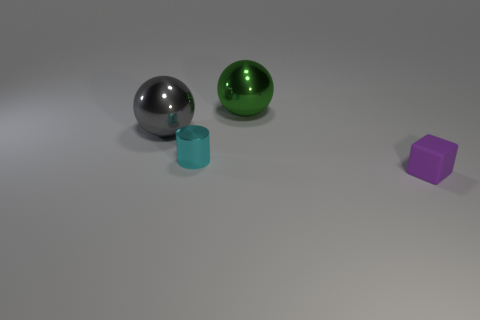Add 4 cyan cylinders. How many objects exist? 8 Subtract all blocks. How many objects are left? 3 Add 4 large gray metallic balls. How many large gray metallic balls exist? 5 Subtract 0 red blocks. How many objects are left? 4 Subtract all balls. Subtract all metal spheres. How many objects are left? 0 Add 1 gray balls. How many gray balls are left? 2 